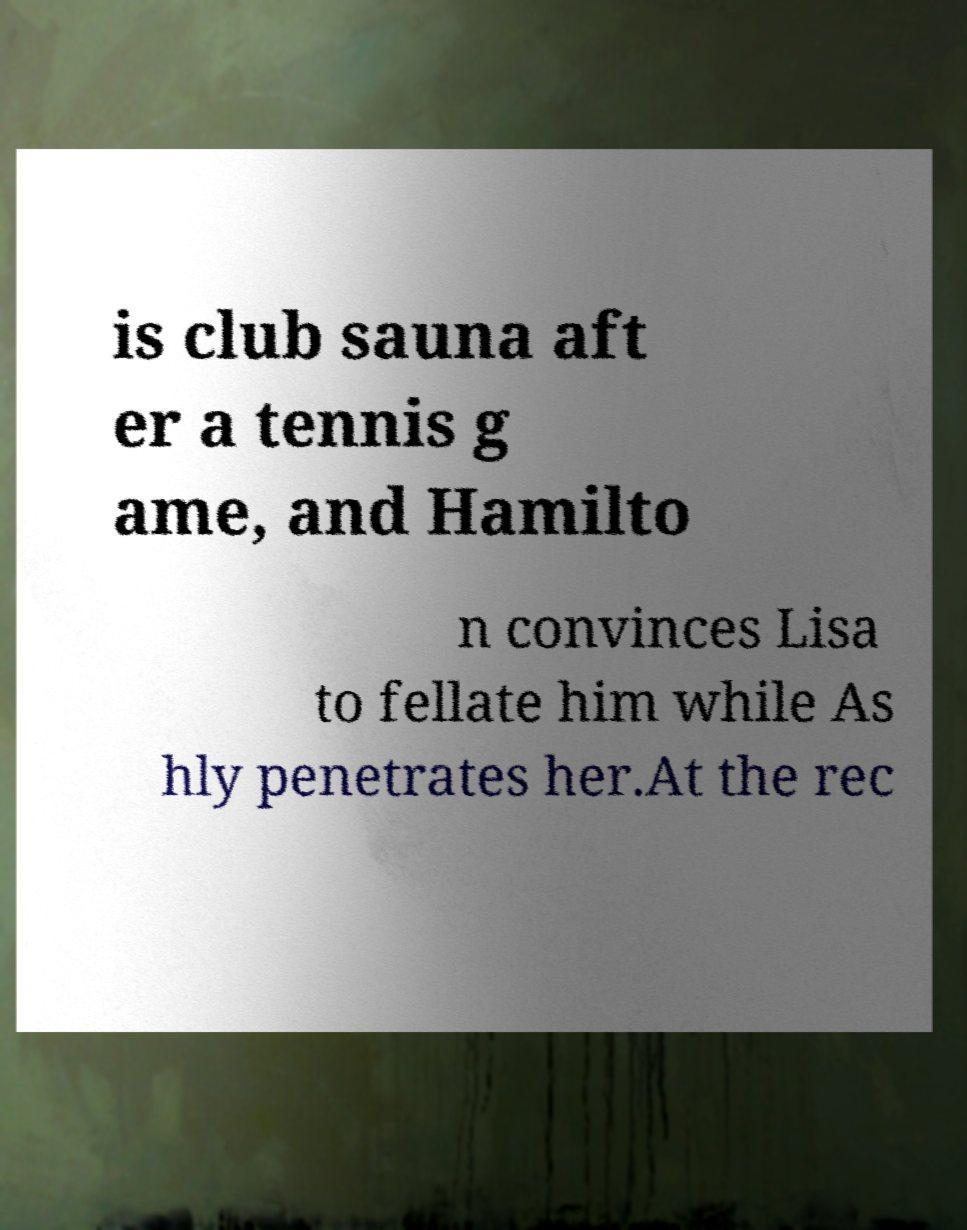Can you accurately transcribe the text from the provided image for me? is club sauna aft er a tennis g ame, and Hamilto n convinces Lisa to fellate him while As hly penetrates her.At the rec 